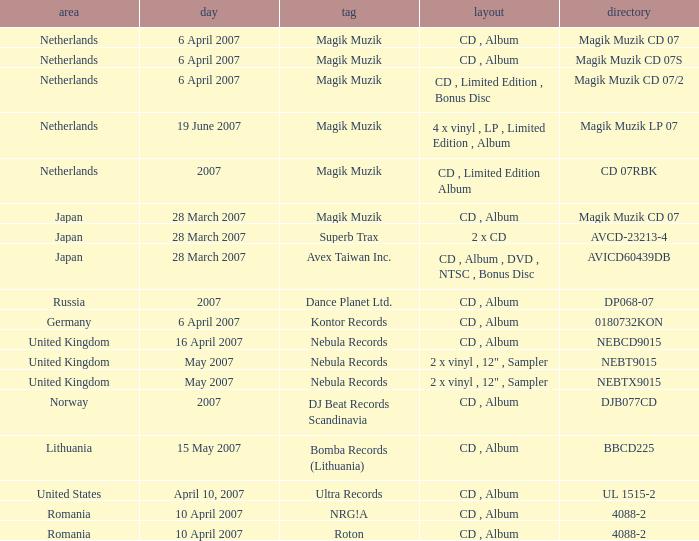For the catalog title DP068-07, what formats are available? CD , Album. 